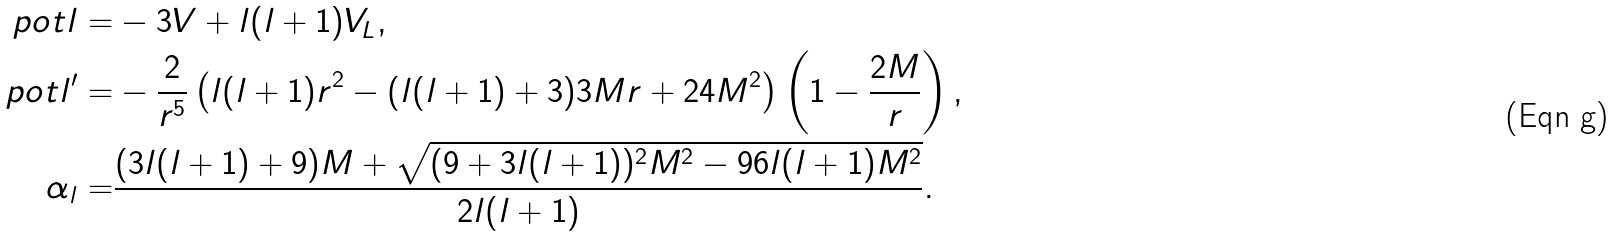<formula> <loc_0><loc_0><loc_500><loc_500>\ p o t l = & - 3 V + l ( l + 1 ) V _ { L } , \\ \ p o t l ^ { \prime } = & - \frac { 2 } { r ^ { 5 } } \left ( l ( l + 1 ) r ^ { 2 } - ( l ( l + 1 ) + 3 ) 3 M r + 2 4 M ^ { 2 } \right ) \left ( 1 - \frac { 2 M } { r } \right ) , \\ \alpha _ { l } = & \frac { ( 3 l ( l + 1 ) + 9 ) M + \sqrt { ( 9 + 3 l ( l + 1 ) ) ^ { 2 } M ^ { 2 } - 9 6 l ( l + 1 ) M ^ { 2 } } } { 2 l ( l + 1 ) } .</formula> 